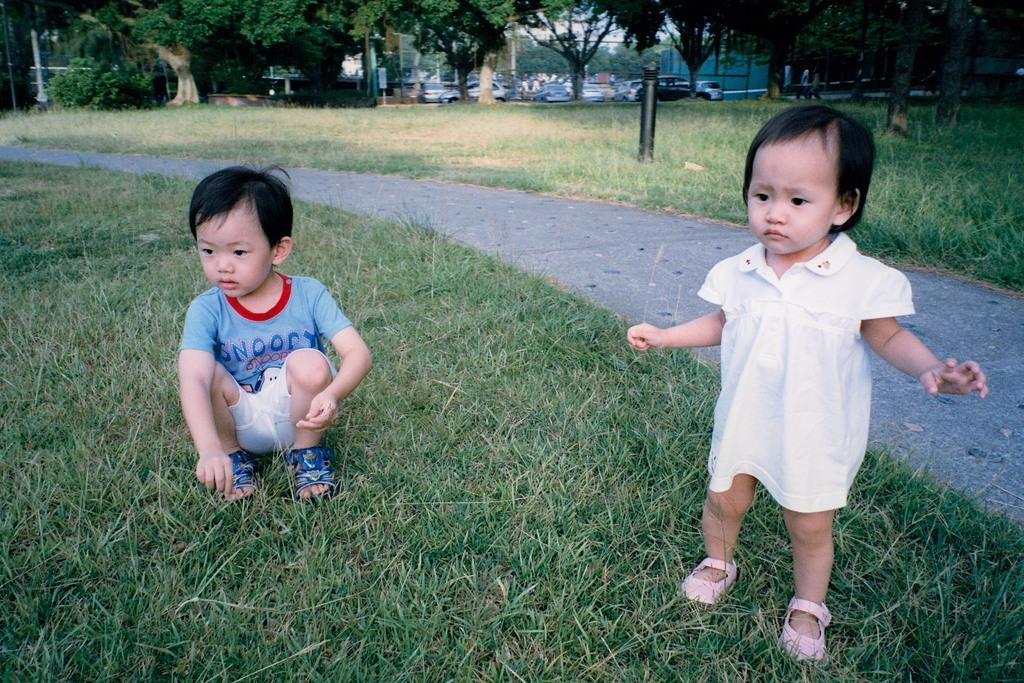Provide a one-sentence caption for the provided image. Baby standing next to another baby that's wearing a shirt that says Snoopy. 